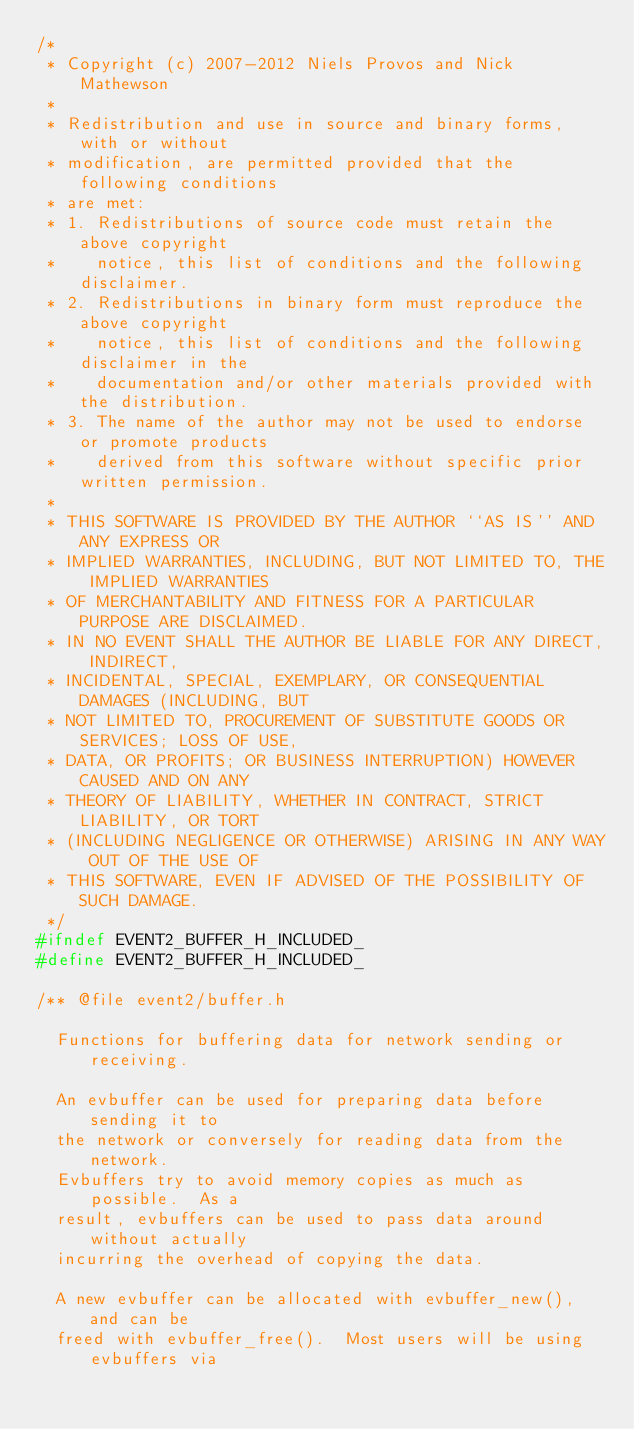Convert code to text. <code><loc_0><loc_0><loc_500><loc_500><_C_>/*
 * Copyright (c) 2007-2012 Niels Provos and Nick Mathewson
 *
 * Redistribution and use in source and binary forms, with or without
 * modification, are permitted provided that the following conditions
 * are met:
 * 1. Redistributions of source code must retain the above copyright
 *    notice, this list of conditions and the following disclaimer.
 * 2. Redistributions in binary form must reproduce the above copyright
 *    notice, this list of conditions and the following disclaimer in the
 *    documentation and/or other materials provided with the distribution.
 * 3. The name of the author may not be used to endorse or promote products
 *    derived from this software without specific prior written permission.
 *
 * THIS SOFTWARE IS PROVIDED BY THE AUTHOR ``AS IS'' AND ANY EXPRESS OR
 * IMPLIED WARRANTIES, INCLUDING, BUT NOT LIMITED TO, THE IMPLIED WARRANTIES
 * OF MERCHANTABILITY AND FITNESS FOR A PARTICULAR PURPOSE ARE DISCLAIMED.
 * IN NO EVENT SHALL THE AUTHOR BE LIABLE FOR ANY DIRECT, INDIRECT,
 * INCIDENTAL, SPECIAL, EXEMPLARY, OR CONSEQUENTIAL DAMAGES (INCLUDING, BUT
 * NOT LIMITED TO, PROCUREMENT OF SUBSTITUTE GOODS OR SERVICES; LOSS OF USE,
 * DATA, OR PROFITS; OR BUSINESS INTERRUPTION) HOWEVER CAUSED AND ON ANY
 * THEORY OF LIABILITY, WHETHER IN CONTRACT, STRICT LIABILITY, OR TORT
 * (INCLUDING NEGLIGENCE OR OTHERWISE) ARISING IN ANY WAY OUT OF THE USE OF
 * THIS SOFTWARE, EVEN IF ADVISED OF THE POSSIBILITY OF SUCH DAMAGE.
 */
#ifndef EVENT2_BUFFER_H_INCLUDED_
#define EVENT2_BUFFER_H_INCLUDED_

/** @file event2/buffer.h

  Functions for buffering data for network sending or receiving.

  An evbuffer can be used for preparing data before sending it to
  the network or conversely for reading data from the network.
  Evbuffers try to avoid memory copies as much as possible.  As a
  result, evbuffers can be used to pass data around without actually
  incurring the overhead of copying the data.

  A new evbuffer can be allocated with evbuffer_new(), and can be
  freed with evbuffer_free().  Most users will be using evbuffers via</code> 